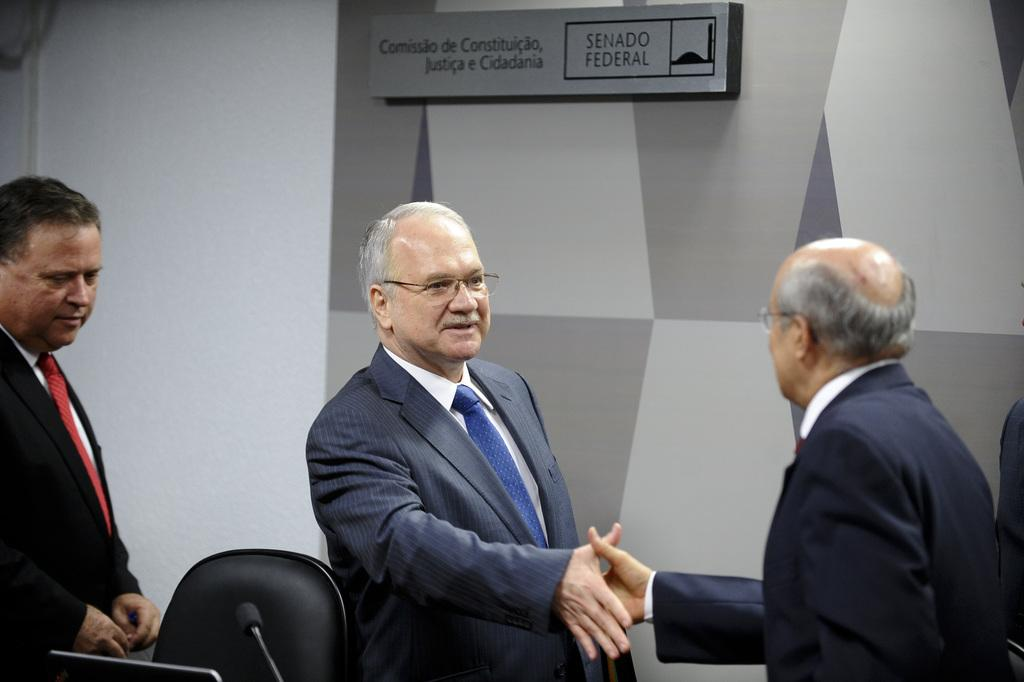What are the two men in the image doing? The two men in the image are shaking hands. Where is the man on the left side of the image positioned? The man on the left side of the image is standing. What can be seen on the wall in the image? There is a name board on the wall. What type of eggs can be seen on the stranger's plate in the image? There is no stranger or plate with eggs present in the image. 